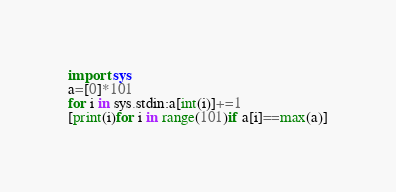Convert code to text. <code><loc_0><loc_0><loc_500><loc_500><_Python_>import sys
a=[0]*101
for i in sys.stdin:a[int(i)]+=1
[print(i)for i in range(101)if a[i]==max(a)]
</code> 